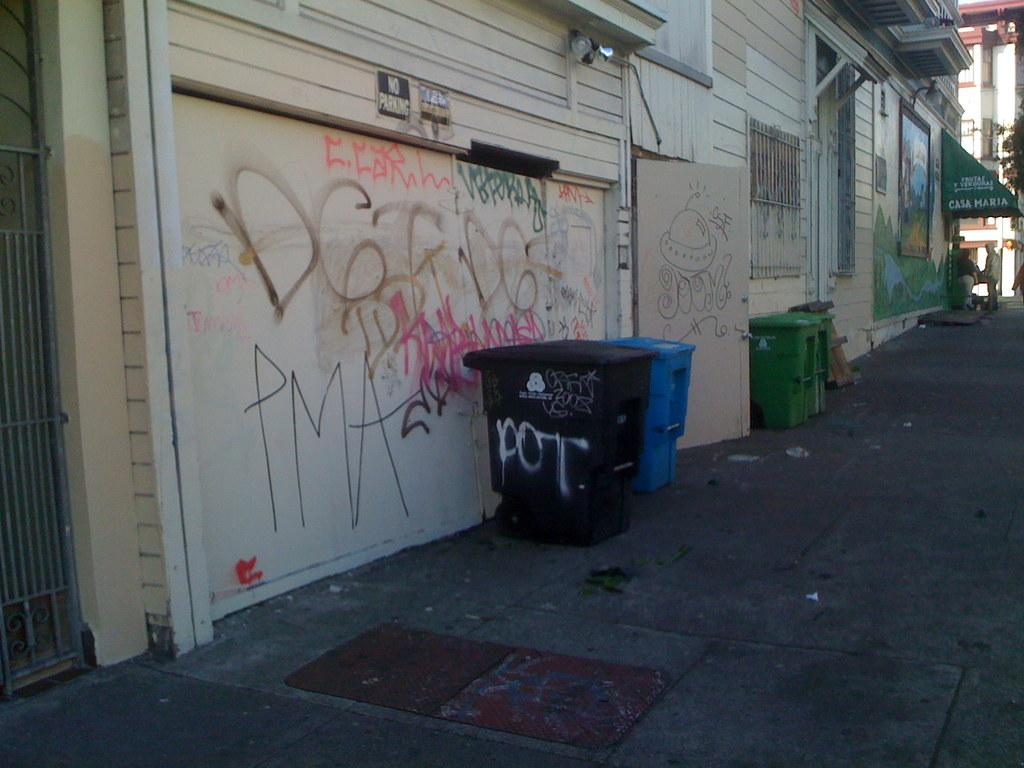<image>
Present a compact description of the photo's key features. A black "no parking" sign is over a garage door covered in graffiti. 